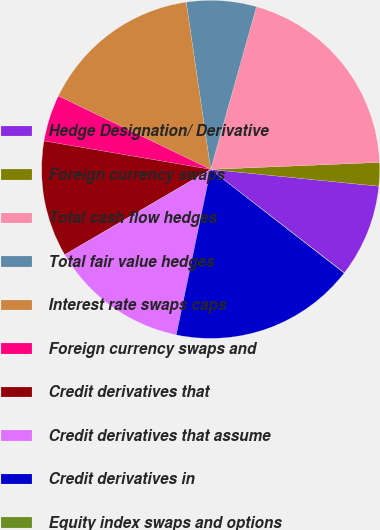Convert chart to OTSL. <chart><loc_0><loc_0><loc_500><loc_500><pie_chart><fcel>Hedge Designation/ Derivative<fcel>Foreign currency swaps<fcel>Total cash flow hedges<fcel>Total fair value hedges<fcel>Interest rate swaps caps<fcel>Foreign currency swaps and<fcel>Credit derivatives that<fcel>Credit derivatives that assume<fcel>Credit derivatives in<fcel>Equity index swaps and options<nl><fcel>8.89%<fcel>2.25%<fcel>19.97%<fcel>6.68%<fcel>15.54%<fcel>4.46%<fcel>11.11%<fcel>13.32%<fcel>17.75%<fcel>0.03%<nl></chart> 